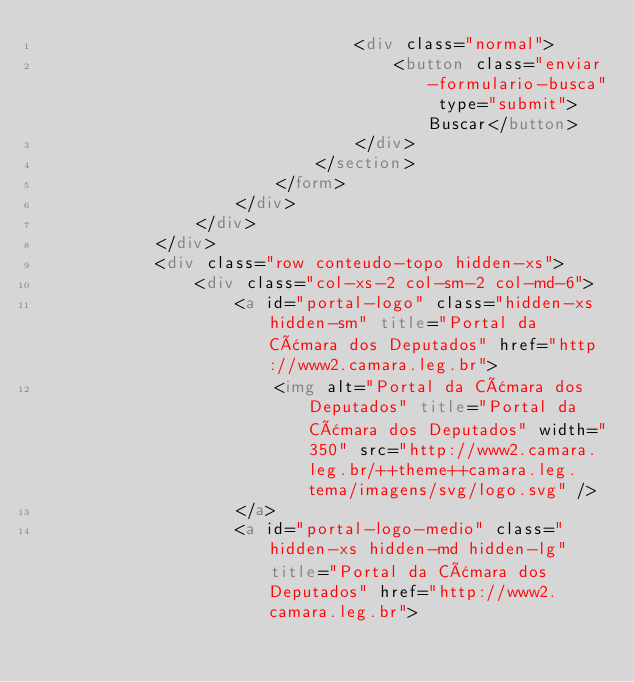<code> <loc_0><loc_0><loc_500><loc_500><_HTML_>                                <div class="normal">
                                    <button class="enviar-formulario-busca" type="submit">Buscar</button>
                                </div>
                            </section>
                        </form>
                    </div>
                </div>
            </div>
            <div class="row conteudo-topo hidden-xs">
                <div class="col-xs-2 col-sm-2 col-md-6">
                    <a id="portal-logo" class="hidden-xs hidden-sm" title="Portal da Câmara dos Deputados" href="http://www2.camara.leg.br">
                        <img alt="Portal da Câmara dos Deputados" title="Portal da Câmara dos Deputados" width="350" src="http://www2.camara.leg.br/++theme++camara.leg.tema/imagens/svg/logo.svg" />
                    </a>
                    <a id="portal-logo-medio" class="hidden-xs hidden-md hidden-lg" title="Portal da Câmara dos Deputados" href="http://www2.camara.leg.br"></code> 